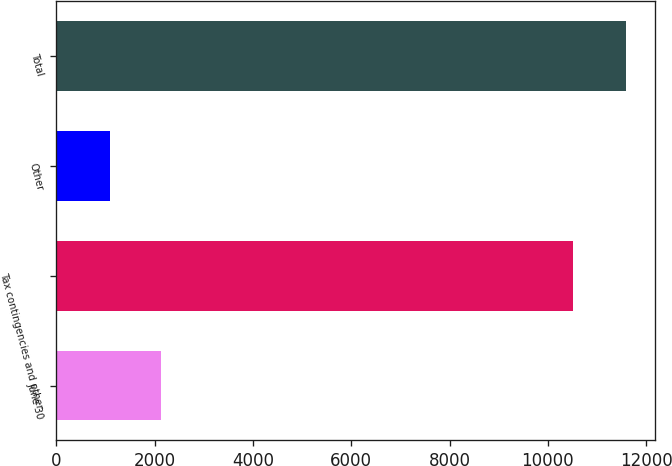Convert chart to OTSL. <chart><loc_0><loc_0><loc_500><loc_500><bar_chart><fcel>June 30<fcel>Tax contingencies and other<fcel>Other<fcel>Total<nl><fcel>2135<fcel>10510<fcel>1084<fcel>11594<nl></chart> 